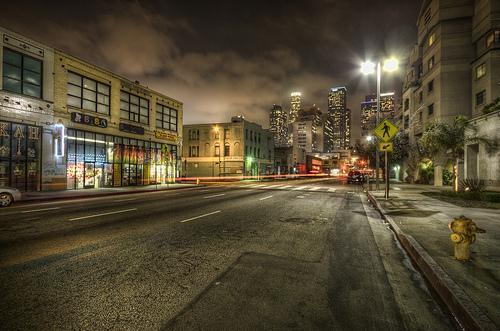How many hydrants are there?
Give a very brief answer. 1. 